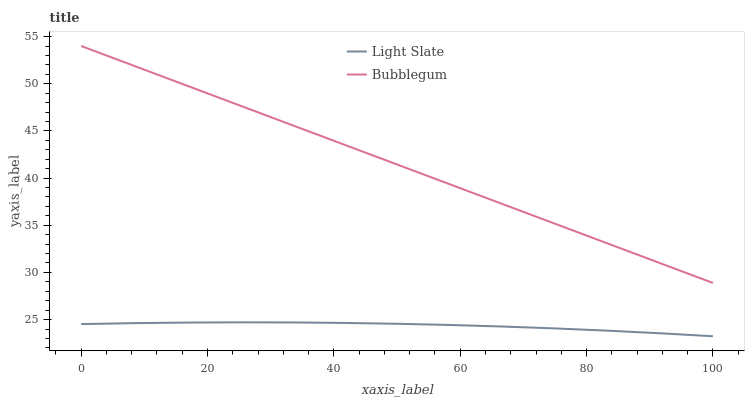Does Light Slate have the minimum area under the curve?
Answer yes or no. Yes. Does Bubblegum have the maximum area under the curve?
Answer yes or no. Yes. Does Bubblegum have the minimum area under the curve?
Answer yes or no. No. Is Bubblegum the smoothest?
Answer yes or no. Yes. Is Light Slate the roughest?
Answer yes or no. Yes. Is Bubblegum the roughest?
Answer yes or no. No. Does Light Slate have the lowest value?
Answer yes or no. Yes. Does Bubblegum have the lowest value?
Answer yes or no. No. Does Bubblegum have the highest value?
Answer yes or no. Yes. Is Light Slate less than Bubblegum?
Answer yes or no. Yes. Is Bubblegum greater than Light Slate?
Answer yes or no. Yes. Does Light Slate intersect Bubblegum?
Answer yes or no. No. 